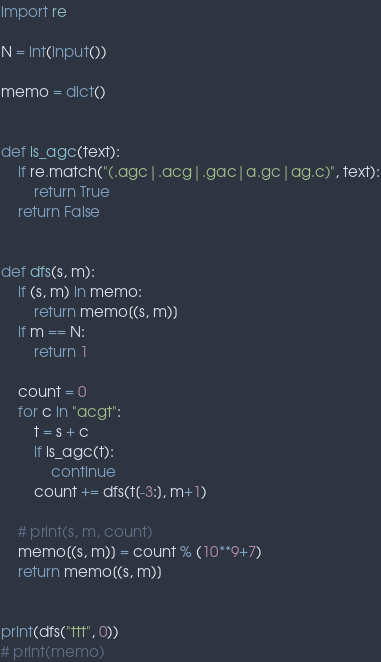<code> <loc_0><loc_0><loc_500><loc_500><_Python_>import re

N = int(input())

memo = dict()


def is_agc(text):
    if re.match("(.agc|.acg|.gac|a.gc|ag.c)", text):
        return True
    return False


def dfs(s, m):
    if (s, m) in memo:
        return memo[(s, m)]
    if m == N:
        return 1

    count = 0
    for c in "acgt":
        t = s + c
        if is_agc(t):
            continue
        count += dfs(t[-3:], m+1)

    # print(s, m, count)
    memo[(s, m)] = count % (10**9+7)
    return memo[(s, m)]


print(dfs("ttt", 0))
# print(memo)</code> 